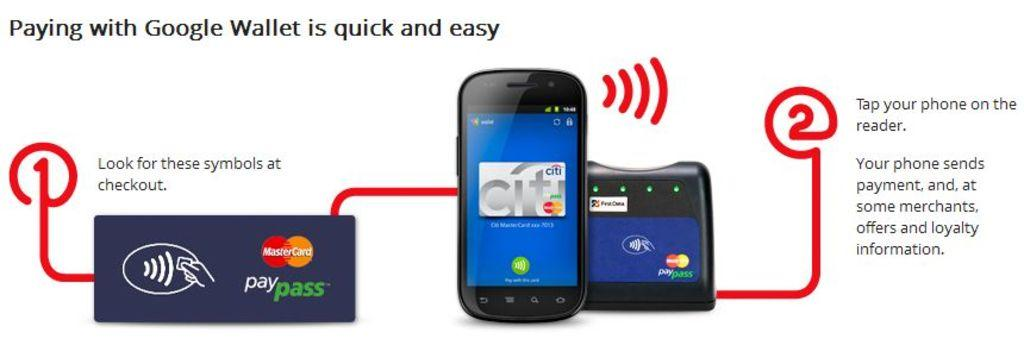<image>
Render a clear and concise summary of the photo. An Google Wallet infographic shows how easy it is to pay with Google Wallet. 